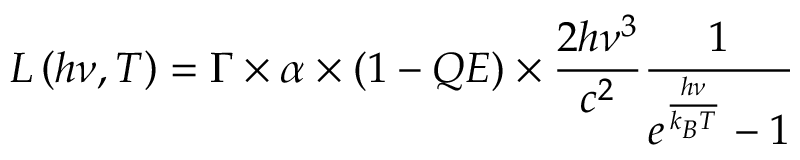Convert formula to latex. <formula><loc_0><loc_0><loc_500><loc_500>L \left ( h \nu , T \right ) = \Gamma \times \alpha \times ( 1 - Q E ) \times \frac { 2 h \nu ^ { 3 } } { c ^ { 2 } } \frac { 1 } { e ^ { \frac { h \nu } { k _ { B } T } } - 1 }</formula> 